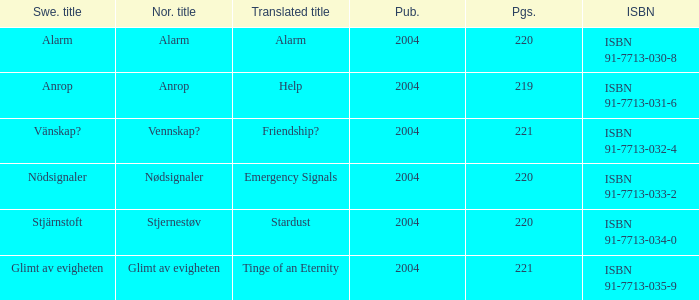How many pages associated with isbn 91-7713-035-9? 221.0. 